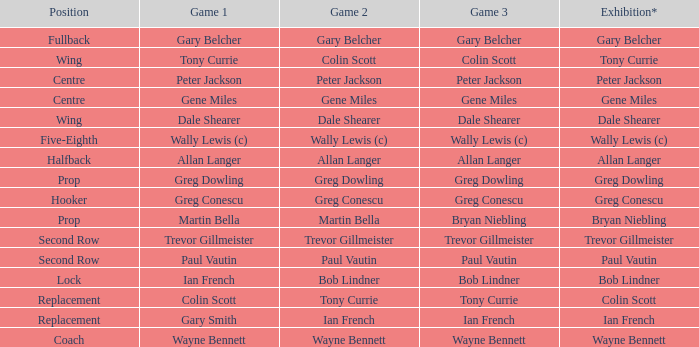What game features bob lindner in a similar role as in game 2? Ian French. 